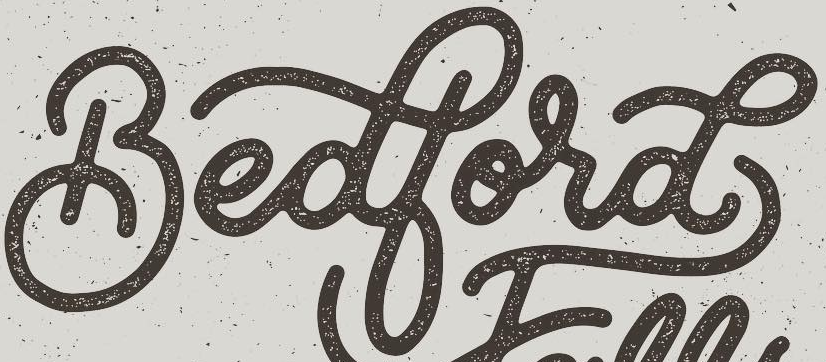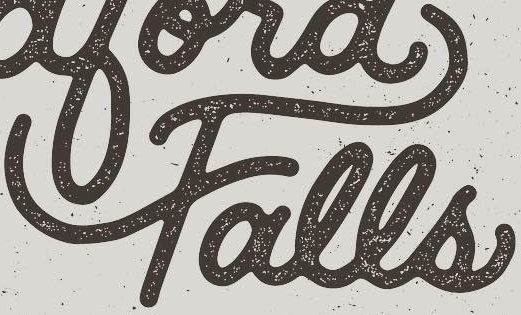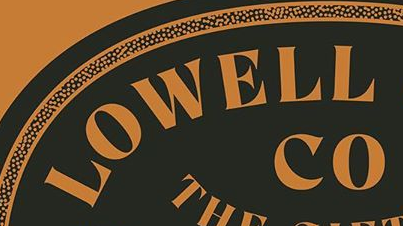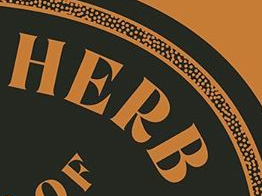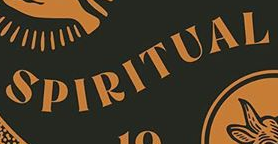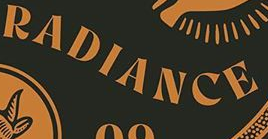What words can you see in these images in sequence, separated by a semicolon? Bedbord; Falls; LOWELL; HERB; SPIRITUAL; RADIANCE 